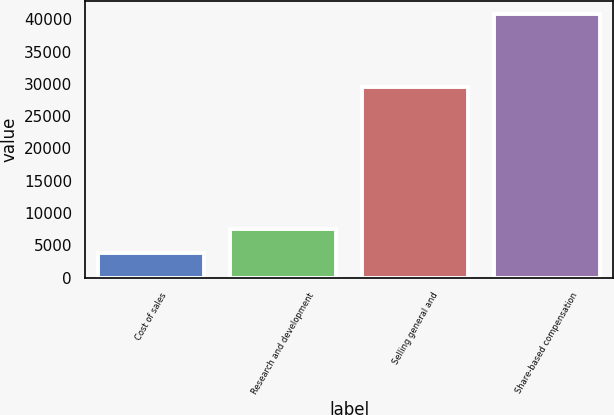Convert chart to OTSL. <chart><loc_0><loc_0><loc_500><loc_500><bar_chart><fcel>Cost of sales<fcel>Research and development<fcel>Selling general and<fcel>Share-based compensation<nl><fcel>3857<fcel>7545.4<fcel>29465<fcel>40741<nl></chart> 